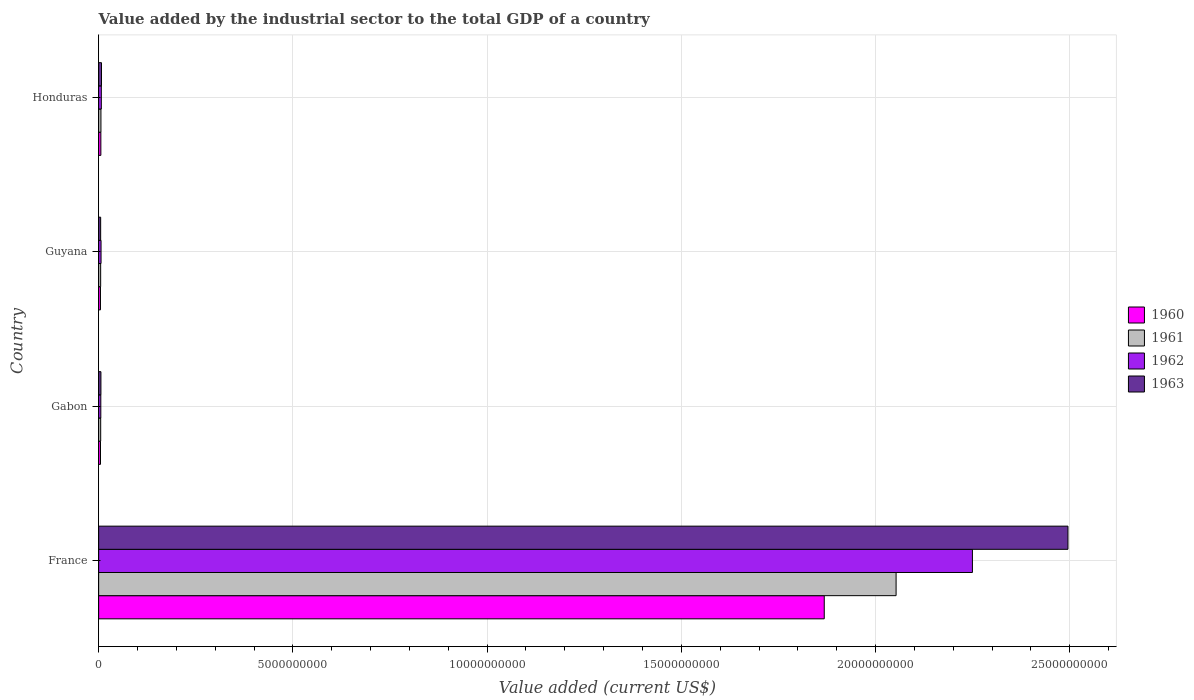How many groups of bars are there?
Ensure brevity in your answer.  4. How many bars are there on the 1st tick from the top?
Your response must be concise. 4. What is the label of the 1st group of bars from the top?
Your response must be concise. Honduras. In how many cases, is the number of bars for a given country not equal to the number of legend labels?
Your answer should be compact. 0. What is the value added by the industrial sector to the total GDP in 1961 in Gabon?
Your answer should be compact. 5.29e+07. Across all countries, what is the maximum value added by the industrial sector to the total GDP in 1961?
Offer a terse response. 2.05e+1. Across all countries, what is the minimum value added by the industrial sector to the total GDP in 1962?
Ensure brevity in your answer.  5.59e+07. In which country was the value added by the industrial sector to the total GDP in 1962 minimum?
Provide a short and direct response. Gabon. What is the total value added by the industrial sector to the total GDP in 1962 in the graph?
Offer a very short reply. 2.27e+1. What is the difference between the value added by the industrial sector to the total GDP in 1963 in France and that in Guyana?
Keep it short and to the point. 2.49e+1. What is the difference between the value added by the industrial sector to the total GDP in 1961 in Guyana and the value added by the industrial sector to the total GDP in 1963 in France?
Provide a succinct answer. -2.49e+1. What is the average value added by the industrial sector to the total GDP in 1960 per country?
Give a very brief answer. 4.71e+09. What is the difference between the value added by the industrial sector to the total GDP in 1960 and value added by the industrial sector to the total GDP in 1963 in Guyana?
Offer a very short reply. -4.67e+06. In how many countries, is the value added by the industrial sector to the total GDP in 1963 greater than 3000000000 US$?
Ensure brevity in your answer.  1. What is the ratio of the value added by the industrial sector to the total GDP in 1962 in Guyana to that in Honduras?
Offer a terse response. 0.9. Is the value added by the industrial sector to the total GDP in 1962 in Guyana less than that in Honduras?
Give a very brief answer. Yes. What is the difference between the highest and the second highest value added by the industrial sector to the total GDP in 1961?
Make the answer very short. 2.05e+1. What is the difference between the highest and the lowest value added by the industrial sector to the total GDP in 1960?
Ensure brevity in your answer.  1.86e+1. In how many countries, is the value added by the industrial sector to the total GDP in 1962 greater than the average value added by the industrial sector to the total GDP in 1962 taken over all countries?
Make the answer very short. 1. Is the sum of the value added by the industrial sector to the total GDP in 1963 in France and Honduras greater than the maximum value added by the industrial sector to the total GDP in 1961 across all countries?
Your answer should be very brief. Yes. How many countries are there in the graph?
Provide a succinct answer. 4. What is the difference between two consecutive major ticks on the X-axis?
Give a very brief answer. 5.00e+09. Does the graph contain any zero values?
Keep it short and to the point. No. How many legend labels are there?
Your response must be concise. 4. What is the title of the graph?
Your response must be concise. Value added by the industrial sector to the total GDP of a country. Does "1982" appear as one of the legend labels in the graph?
Ensure brevity in your answer.  No. What is the label or title of the X-axis?
Provide a short and direct response. Value added (current US$). What is the label or title of the Y-axis?
Offer a terse response. Country. What is the Value added (current US$) of 1960 in France?
Your response must be concise. 1.87e+1. What is the Value added (current US$) of 1961 in France?
Offer a very short reply. 2.05e+1. What is the Value added (current US$) of 1962 in France?
Your answer should be compact. 2.25e+1. What is the Value added (current US$) in 1963 in France?
Your answer should be very brief. 2.50e+1. What is the Value added (current US$) of 1960 in Gabon?
Provide a succinct answer. 4.80e+07. What is the Value added (current US$) of 1961 in Gabon?
Your response must be concise. 5.29e+07. What is the Value added (current US$) in 1962 in Gabon?
Your answer should be compact. 5.59e+07. What is the Value added (current US$) in 1963 in Gabon?
Make the answer very short. 5.89e+07. What is the Value added (current US$) of 1960 in Guyana?
Offer a very short reply. 4.74e+07. What is the Value added (current US$) of 1961 in Guyana?
Provide a succinct answer. 5.23e+07. What is the Value added (current US$) in 1962 in Guyana?
Your answer should be very brief. 6.20e+07. What is the Value added (current US$) of 1963 in Guyana?
Make the answer very short. 5.21e+07. What is the Value added (current US$) in 1960 in Honduras?
Provide a succinct answer. 5.73e+07. What is the Value added (current US$) of 1961 in Honduras?
Your answer should be compact. 5.94e+07. What is the Value added (current US$) in 1962 in Honduras?
Offer a terse response. 6.92e+07. What is the Value added (current US$) of 1963 in Honduras?
Give a very brief answer. 7.38e+07. Across all countries, what is the maximum Value added (current US$) in 1960?
Your answer should be very brief. 1.87e+1. Across all countries, what is the maximum Value added (current US$) in 1961?
Provide a succinct answer. 2.05e+1. Across all countries, what is the maximum Value added (current US$) in 1962?
Make the answer very short. 2.25e+1. Across all countries, what is the maximum Value added (current US$) of 1963?
Provide a short and direct response. 2.50e+1. Across all countries, what is the minimum Value added (current US$) in 1960?
Keep it short and to the point. 4.74e+07. Across all countries, what is the minimum Value added (current US$) in 1961?
Offer a very short reply. 5.23e+07. Across all countries, what is the minimum Value added (current US$) of 1962?
Make the answer very short. 5.59e+07. Across all countries, what is the minimum Value added (current US$) of 1963?
Provide a succinct answer. 5.21e+07. What is the total Value added (current US$) in 1960 in the graph?
Your answer should be very brief. 1.88e+1. What is the total Value added (current US$) of 1961 in the graph?
Your answer should be compact. 2.07e+1. What is the total Value added (current US$) of 1962 in the graph?
Offer a very short reply. 2.27e+1. What is the total Value added (current US$) in 1963 in the graph?
Ensure brevity in your answer.  2.51e+1. What is the difference between the Value added (current US$) in 1960 in France and that in Gabon?
Provide a short and direct response. 1.86e+1. What is the difference between the Value added (current US$) in 1961 in France and that in Gabon?
Your answer should be very brief. 2.05e+1. What is the difference between the Value added (current US$) of 1962 in France and that in Gabon?
Offer a very short reply. 2.24e+1. What is the difference between the Value added (current US$) in 1963 in France and that in Gabon?
Your answer should be very brief. 2.49e+1. What is the difference between the Value added (current US$) in 1960 in France and that in Guyana?
Your response must be concise. 1.86e+1. What is the difference between the Value added (current US$) of 1961 in France and that in Guyana?
Offer a terse response. 2.05e+1. What is the difference between the Value added (current US$) of 1962 in France and that in Guyana?
Provide a short and direct response. 2.24e+1. What is the difference between the Value added (current US$) of 1963 in France and that in Guyana?
Provide a short and direct response. 2.49e+1. What is the difference between the Value added (current US$) of 1960 in France and that in Honduras?
Provide a short and direct response. 1.86e+1. What is the difference between the Value added (current US$) of 1961 in France and that in Honduras?
Give a very brief answer. 2.05e+1. What is the difference between the Value added (current US$) of 1962 in France and that in Honduras?
Make the answer very short. 2.24e+1. What is the difference between the Value added (current US$) of 1963 in France and that in Honduras?
Ensure brevity in your answer.  2.49e+1. What is the difference between the Value added (current US$) in 1960 in Gabon and that in Guyana?
Offer a very short reply. 5.58e+05. What is the difference between the Value added (current US$) in 1961 in Gabon and that in Guyana?
Give a very brief answer. 6.49e+05. What is the difference between the Value added (current US$) of 1962 in Gabon and that in Guyana?
Your response must be concise. -6.07e+06. What is the difference between the Value added (current US$) in 1963 in Gabon and that in Guyana?
Offer a very short reply. 6.82e+06. What is the difference between the Value added (current US$) of 1960 in Gabon and that in Honduras?
Provide a succinct answer. -9.32e+06. What is the difference between the Value added (current US$) in 1961 in Gabon and that in Honduras?
Your answer should be very brief. -6.43e+06. What is the difference between the Value added (current US$) in 1962 in Gabon and that in Honduras?
Keep it short and to the point. -1.33e+07. What is the difference between the Value added (current US$) of 1963 in Gabon and that in Honduras?
Provide a short and direct response. -1.49e+07. What is the difference between the Value added (current US$) in 1960 in Guyana and that in Honduras?
Ensure brevity in your answer.  -9.88e+06. What is the difference between the Value added (current US$) in 1961 in Guyana and that in Honduras?
Ensure brevity in your answer.  -7.08e+06. What is the difference between the Value added (current US$) in 1962 in Guyana and that in Honduras?
Provide a succinct answer. -7.19e+06. What is the difference between the Value added (current US$) of 1963 in Guyana and that in Honduras?
Your answer should be compact. -2.17e+07. What is the difference between the Value added (current US$) of 1960 in France and the Value added (current US$) of 1961 in Gabon?
Make the answer very short. 1.86e+1. What is the difference between the Value added (current US$) of 1960 in France and the Value added (current US$) of 1962 in Gabon?
Ensure brevity in your answer.  1.86e+1. What is the difference between the Value added (current US$) in 1960 in France and the Value added (current US$) in 1963 in Gabon?
Your response must be concise. 1.86e+1. What is the difference between the Value added (current US$) of 1961 in France and the Value added (current US$) of 1962 in Gabon?
Keep it short and to the point. 2.05e+1. What is the difference between the Value added (current US$) in 1961 in France and the Value added (current US$) in 1963 in Gabon?
Offer a very short reply. 2.05e+1. What is the difference between the Value added (current US$) in 1962 in France and the Value added (current US$) in 1963 in Gabon?
Keep it short and to the point. 2.24e+1. What is the difference between the Value added (current US$) in 1960 in France and the Value added (current US$) in 1961 in Guyana?
Your response must be concise. 1.86e+1. What is the difference between the Value added (current US$) of 1960 in France and the Value added (current US$) of 1962 in Guyana?
Keep it short and to the point. 1.86e+1. What is the difference between the Value added (current US$) in 1960 in France and the Value added (current US$) in 1963 in Guyana?
Ensure brevity in your answer.  1.86e+1. What is the difference between the Value added (current US$) in 1961 in France and the Value added (current US$) in 1962 in Guyana?
Offer a very short reply. 2.05e+1. What is the difference between the Value added (current US$) in 1961 in France and the Value added (current US$) in 1963 in Guyana?
Provide a succinct answer. 2.05e+1. What is the difference between the Value added (current US$) in 1962 in France and the Value added (current US$) in 1963 in Guyana?
Ensure brevity in your answer.  2.24e+1. What is the difference between the Value added (current US$) in 1960 in France and the Value added (current US$) in 1961 in Honduras?
Offer a terse response. 1.86e+1. What is the difference between the Value added (current US$) of 1960 in France and the Value added (current US$) of 1962 in Honduras?
Offer a terse response. 1.86e+1. What is the difference between the Value added (current US$) in 1960 in France and the Value added (current US$) in 1963 in Honduras?
Offer a terse response. 1.86e+1. What is the difference between the Value added (current US$) of 1961 in France and the Value added (current US$) of 1962 in Honduras?
Make the answer very short. 2.05e+1. What is the difference between the Value added (current US$) of 1961 in France and the Value added (current US$) of 1963 in Honduras?
Your response must be concise. 2.05e+1. What is the difference between the Value added (current US$) in 1962 in France and the Value added (current US$) in 1963 in Honduras?
Keep it short and to the point. 2.24e+1. What is the difference between the Value added (current US$) of 1960 in Gabon and the Value added (current US$) of 1961 in Guyana?
Provide a short and direct response. -4.28e+06. What is the difference between the Value added (current US$) in 1960 in Gabon and the Value added (current US$) in 1962 in Guyana?
Ensure brevity in your answer.  -1.40e+07. What is the difference between the Value added (current US$) in 1960 in Gabon and the Value added (current US$) in 1963 in Guyana?
Make the answer very short. -4.11e+06. What is the difference between the Value added (current US$) in 1961 in Gabon and the Value added (current US$) in 1962 in Guyana?
Your answer should be compact. -9.09e+06. What is the difference between the Value added (current US$) in 1961 in Gabon and the Value added (current US$) in 1963 in Guyana?
Keep it short and to the point. 8.24e+05. What is the difference between the Value added (current US$) of 1962 in Gabon and the Value added (current US$) of 1963 in Guyana?
Provide a short and direct response. 3.85e+06. What is the difference between the Value added (current US$) in 1960 in Gabon and the Value added (current US$) in 1961 in Honduras?
Your answer should be compact. -1.14e+07. What is the difference between the Value added (current US$) of 1960 in Gabon and the Value added (current US$) of 1962 in Honduras?
Give a very brief answer. -2.12e+07. What is the difference between the Value added (current US$) in 1960 in Gabon and the Value added (current US$) in 1963 in Honduras?
Your answer should be very brief. -2.58e+07. What is the difference between the Value added (current US$) of 1961 in Gabon and the Value added (current US$) of 1962 in Honduras?
Make the answer very short. -1.63e+07. What is the difference between the Value added (current US$) of 1961 in Gabon and the Value added (current US$) of 1963 in Honduras?
Provide a succinct answer. -2.09e+07. What is the difference between the Value added (current US$) of 1962 in Gabon and the Value added (current US$) of 1963 in Honduras?
Provide a succinct answer. -1.79e+07. What is the difference between the Value added (current US$) of 1960 in Guyana and the Value added (current US$) of 1961 in Honduras?
Offer a terse response. -1.19e+07. What is the difference between the Value added (current US$) in 1960 in Guyana and the Value added (current US$) in 1962 in Honduras?
Keep it short and to the point. -2.18e+07. What is the difference between the Value added (current US$) in 1960 in Guyana and the Value added (current US$) in 1963 in Honduras?
Ensure brevity in your answer.  -2.64e+07. What is the difference between the Value added (current US$) in 1961 in Guyana and the Value added (current US$) in 1962 in Honduras?
Make the answer very short. -1.69e+07. What is the difference between the Value added (current US$) in 1961 in Guyana and the Value added (current US$) in 1963 in Honduras?
Make the answer very short. -2.15e+07. What is the difference between the Value added (current US$) in 1962 in Guyana and the Value added (current US$) in 1963 in Honduras?
Provide a short and direct response. -1.18e+07. What is the average Value added (current US$) of 1960 per country?
Your answer should be very brief. 4.71e+09. What is the average Value added (current US$) in 1961 per country?
Your response must be concise. 5.17e+09. What is the average Value added (current US$) in 1962 per country?
Keep it short and to the point. 5.67e+09. What is the average Value added (current US$) of 1963 per country?
Your answer should be very brief. 6.28e+09. What is the difference between the Value added (current US$) in 1960 and Value added (current US$) in 1961 in France?
Offer a terse response. -1.85e+09. What is the difference between the Value added (current US$) of 1960 and Value added (current US$) of 1962 in France?
Your answer should be very brief. -3.81e+09. What is the difference between the Value added (current US$) of 1960 and Value added (current US$) of 1963 in France?
Keep it short and to the point. -6.27e+09. What is the difference between the Value added (current US$) in 1961 and Value added (current US$) in 1962 in France?
Provide a short and direct response. -1.97e+09. What is the difference between the Value added (current US$) of 1961 and Value added (current US$) of 1963 in France?
Provide a short and direct response. -4.42e+09. What is the difference between the Value added (current US$) in 1962 and Value added (current US$) in 1963 in France?
Provide a short and direct response. -2.46e+09. What is the difference between the Value added (current US$) of 1960 and Value added (current US$) of 1961 in Gabon?
Offer a very short reply. -4.93e+06. What is the difference between the Value added (current US$) in 1960 and Value added (current US$) in 1962 in Gabon?
Offer a terse response. -7.96e+06. What is the difference between the Value added (current US$) of 1960 and Value added (current US$) of 1963 in Gabon?
Make the answer very short. -1.09e+07. What is the difference between the Value added (current US$) in 1961 and Value added (current US$) in 1962 in Gabon?
Provide a succinct answer. -3.02e+06. What is the difference between the Value added (current US$) in 1961 and Value added (current US$) in 1963 in Gabon?
Your answer should be very brief. -5.99e+06. What is the difference between the Value added (current US$) in 1962 and Value added (current US$) in 1963 in Gabon?
Give a very brief answer. -2.97e+06. What is the difference between the Value added (current US$) in 1960 and Value added (current US$) in 1961 in Guyana?
Offer a terse response. -4.84e+06. What is the difference between the Value added (current US$) of 1960 and Value added (current US$) of 1962 in Guyana?
Your response must be concise. -1.46e+07. What is the difference between the Value added (current US$) of 1960 and Value added (current US$) of 1963 in Guyana?
Provide a succinct answer. -4.67e+06. What is the difference between the Value added (current US$) of 1961 and Value added (current US$) of 1962 in Guyana?
Offer a terse response. -9.74e+06. What is the difference between the Value added (current US$) of 1961 and Value added (current US$) of 1963 in Guyana?
Give a very brief answer. 1.75e+05. What is the difference between the Value added (current US$) of 1962 and Value added (current US$) of 1963 in Guyana?
Make the answer very short. 9.92e+06. What is the difference between the Value added (current US$) in 1960 and Value added (current US$) in 1961 in Honduras?
Provide a short and direct response. -2.05e+06. What is the difference between the Value added (current US$) of 1960 and Value added (current US$) of 1962 in Honduras?
Keep it short and to the point. -1.19e+07. What is the difference between the Value added (current US$) of 1960 and Value added (current US$) of 1963 in Honduras?
Your answer should be compact. -1.65e+07. What is the difference between the Value added (current US$) in 1961 and Value added (current US$) in 1962 in Honduras?
Offer a very short reply. -9.85e+06. What is the difference between the Value added (current US$) in 1961 and Value added (current US$) in 1963 in Honduras?
Offer a terse response. -1.44e+07. What is the difference between the Value added (current US$) in 1962 and Value added (current US$) in 1963 in Honduras?
Offer a terse response. -4.60e+06. What is the ratio of the Value added (current US$) of 1960 in France to that in Gabon?
Give a very brief answer. 389.29. What is the ratio of the Value added (current US$) of 1961 in France to that in Gabon?
Offer a terse response. 387.95. What is the ratio of the Value added (current US$) of 1962 in France to that in Gabon?
Offer a very short reply. 402.11. What is the ratio of the Value added (current US$) of 1963 in France to that in Gabon?
Provide a succinct answer. 423.59. What is the ratio of the Value added (current US$) in 1960 in France to that in Guyana?
Make the answer very short. 393.87. What is the ratio of the Value added (current US$) of 1961 in France to that in Guyana?
Offer a very short reply. 392.77. What is the ratio of the Value added (current US$) of 1962 in France to that in Guyana?
Offer a very short reply. 362.76. What is the ratio of the Value added (current US$) of 1963 in France to that in Guyana?
Offer a very short reply. 479.03. What is the ratio of the Value added (current US$) of 1960 in France to that in Honduras?
Make the answer very short. 325.99. What is the ratio of the Value added (current US$) in 1961 in France to that in Honduras?
Make the answer very short. 345.89. What is the ratio of the Value added (current US$) of 1962 in France to that in Honduras?
Keep it short and to the point. 325.06. What is the ratio of the Value added (current US$) in 1963 in France to that in Honduras?
Your response must be concise. 338.12. What is the ratio of the Value added (current US$) of 1960 in Gabon to that in Guyana?
Give a very brief answer. 1.01. What is the ratio of the Value added (current US$) of 1961 in Gabon to that in Guyana?
Your answer should be compact. 1.01. What is the ratio of the Value added (current US$) in 1962 in Gabon to that in Guyana?
Your answer should be compact. 0.9. What is the ratio of the Value added (current US$) in 1963 in Gabon to that in Guyana?
Give a very brief answer. 1.13. What is the ratio of the Value added (current US$) in 1960 in Gabon to that in Honduras?
Your response must be concise. 0.84. What is the ratio of the Value added (current US$) in 1961 in Gabon to that in Honduras?
Provide a succinct answer. 0.89. What is the ratio of the Value added (current US$) of 1962 in Gabon to that in Honduras?
Give a very brief answer. 0.81. What is the ratio of the Value added (current US$) of 1963 in Gabon to that in Honduras?
Provide a succinct answer. 0.8. What is the ratio of the Value added (current US$) in 1960 in Guyana to that in Honduras?
Your answer should be compact. 0.83. What is the ratio of the Value added (current US$) in 1961 in Guyana to that in Honduras?
Your answer should be compact. 0.88. What is the ratio of the Value added (current US$) of 1962 in Guyana to that in Honduras?
Your response must be concise. 0.9. What is the ratio of the Value added (current US$) in 1963 in Guyana to that in Honduras?
Offer a terse response. 0.71. What is the difference between the highest and the second highest Value added (current US$) in 1960?
Your answer should be compact. 1.86e+1. What is the difference between the highest and the second highest Value added (current US$) of 1961?
Offer a very short reply. 2.05e+1. What is the difference between the highest and the second highest Value added (current US$) of 1962?
Provide a short and direct response. 2.24e+1. What is the difference between the highest and the second highest Value added (current US$) in 1963?
Provide a succinct answer. 2.49e+1. What is the difference between the highest and the lowest Value added (current US$) of 1960?
Make the answer very short. 1.86e+1. What is the difference between the highest and the lowest Value added (current US$) in 1961?
Keep it short and to the point. 2.05e+1. What is the difference between the highest and the lowest Value added (current US$) in 1962?
Offer a terse response. 2.24e+1. What is the difference between the highest and the lowest Value added (current US$) of 1963?
Ensure brevity in your answer.  2.49e+1. 